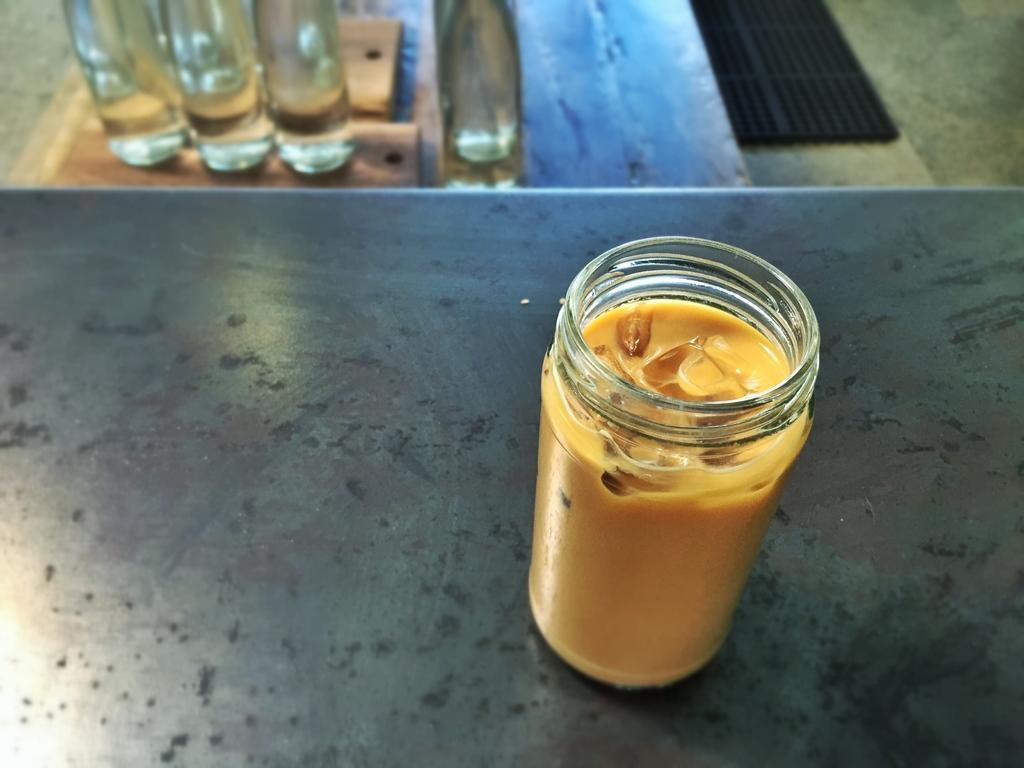Can you describe this image briefly? In this image I can see a glass, inside the glass I can see some liquid in yellow color, at the back I can see few bottles on the wooden surface. 